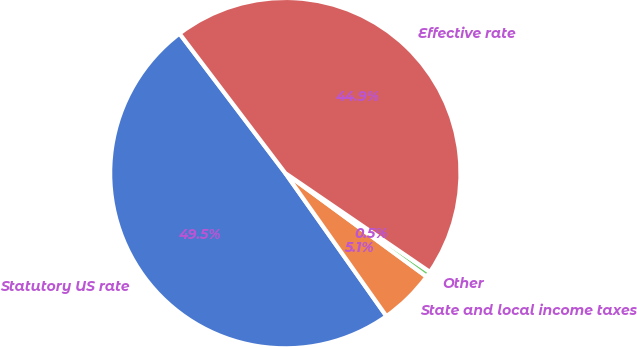Convert chart. <chart><loc_0><loc_0><loc_500><loc_500><pie_chart><fcel>Statutory US rate<fcel>State and local income taxes<fcel>Other<fcel>Effective rate<nl><fcel>49.47%<fcel>5.14%<fcel>0.53%<fcel>44.86%<nl></chart> 